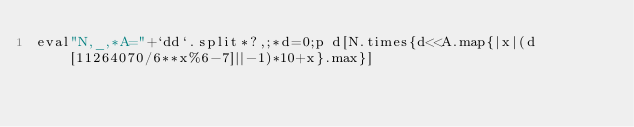<code> <loc_0><loc_0><loc_500><loc_500><_Ruby_>eval"N,_,*A="+`dd`.split*?,;*d=0;p d[N.times{d<<A.map{|x|(d[11264070/6**x%6-7]||-1)*10+x}.max}]</code> 